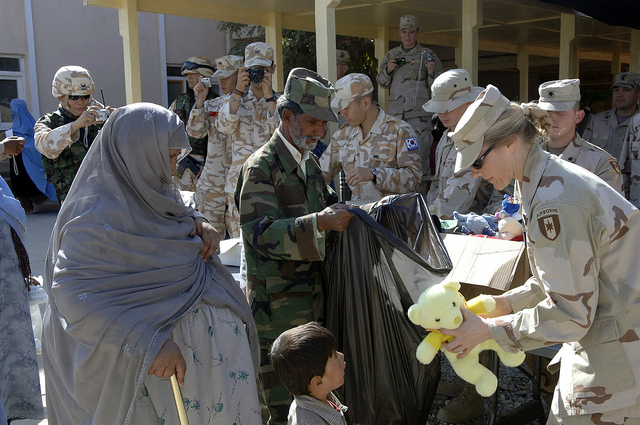What's happening in the scene? The scene depicts a humanitarian event where soldiers are distributing toys and other goods to local civilians, including women and children. A soldier on the right is handing a teddy bear to a child while another soldier, assisted by a man in uniform, holds a large plastic bag filled with items. The background shows numerous soldiers, many of whom are observing or documenting the event with cameras. The atmosphere appears to be one of assistance and benevolence. 